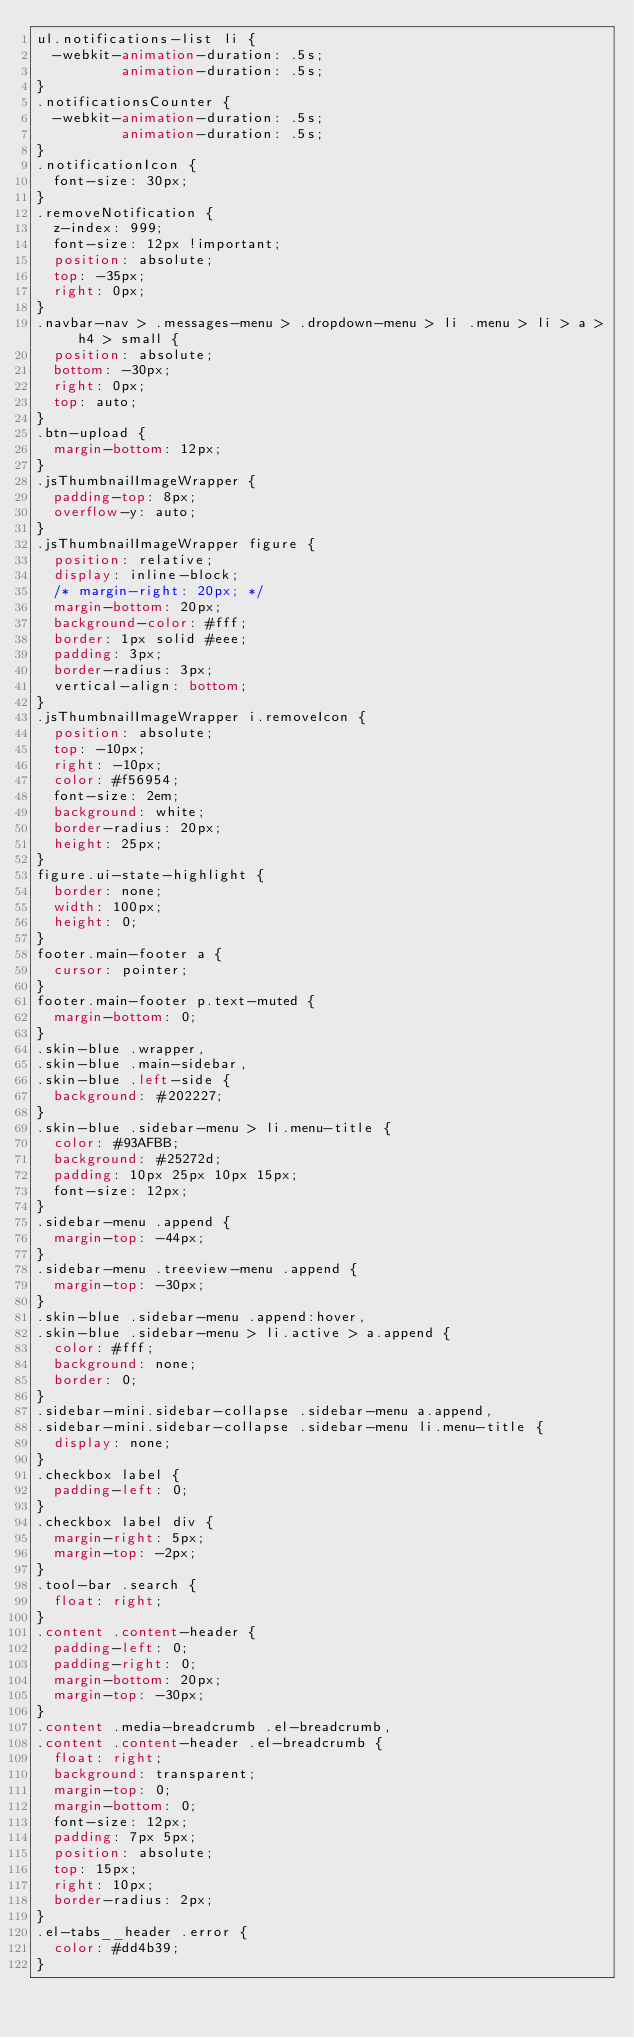Convert code to text. <code><loc_0><loc_0><loc_500><loc_500><_CSS_>ul.notifications-list li {
  -webkit-animation-duration: .5s;
          animation-duration: .5s;
}
.notificationsCounter {
  -webkit-animation-duration: .5s;
          animation-duration: .5s;
}
.notificationIcon {
  font-size: 30px;
}
.removeNotification {
  z-index: 999;
  font-size: 12px !important;
  position: absolute;
  top: -35px;
  right: 0px;
}
.navbar-nav > .messages-menu > .dropdown-menu > li .menu > li > a > h4 > small {
  position: absolute;
  bottom: -30px;
  right: 0px;
  top: auto;
}
.btn-upload {
  margin-bottom: 12px;
}
.jsThumbnailImageWrapper {
  padding-top: 8px;
  overflow-y: auto;
}
.jsThumbnailImageWrapper figure {
  position: relative;
  display: inline-block;
  /* margin-right: 20px; */
  margin-bottom: 20px;
  background-color: #fff;
  border: 1px solid #eee;
  padding: 3px;
  border-radius: 3px;
  vertical-align: bottom;
}
.jsThumbnailImageWrapper i.removeIcon {
  position: absolute;
  top: -10px;
  right: -10px;
  color: #f56954;
  font-size: 2em;
  background: white;
  border-radius: 20px;
  height: 25px;
}
figure.ui-state-highlight {
  border: none;
  width: 100px;
  height: 0;
}
footer.main-footer a {
  cursor: pointer;
}
footer.main-footer p.text-muted {
  margin-bottom: 0;
}
.skin-blue .wrapper,
.skin-blue .main-sidebar,
.skin-blue .left-side {
  background: #202227;
}
.skin-blue .sidebar-menu > li.menu-title {
  color: #93AFBB;
  background: #25272d;
  padding: 10px 25px 10px 15px;
  font-size: 12px;
}
.sidebar-menu .append {
  margin-top: -44px;
}
.sidebar-menu .treeview-menu .append {
  margin-top: -30px;
}
.skin-blue .sidebar-menu .append:hover,
.skin-blue .sidebar-menu > li.active > a.append {
  color: #fff;
  background: none;
  border: 0;
}
.sidebar-mini.sidebar-collapse .sidebar-menu a.append,
.sidebar-mini.sidebar-collapse .sidebar-menu li.menu-title {
  display: none;
}
.checkbox label {
  padding-left: 0;
}
.checkbox label div {
  margin-right: 5px;
  margin-top: -2px;
}
.tool-bar .search {
  float: right;
}
.content .content-header {
  padding-left: 0;
  padding-right: 0;
  margin-bottom: 20px;
  margin-top: -30px;
}
.content .media-breadcrumb .el-breadcrumb,
.content .content-header .el-breadcrumb {
  float: right;
  background: transparent;
  margin-top: 0;
  margin-bottom: 0;
  font-size: 12px;
  padding: 7px 5px;
  position: absolute;
  top: 15px;
  right: 10px;
  border-radius: 2px;
}
.el-tabs__header .error {
  color: #dd4b39;
}
</code> 